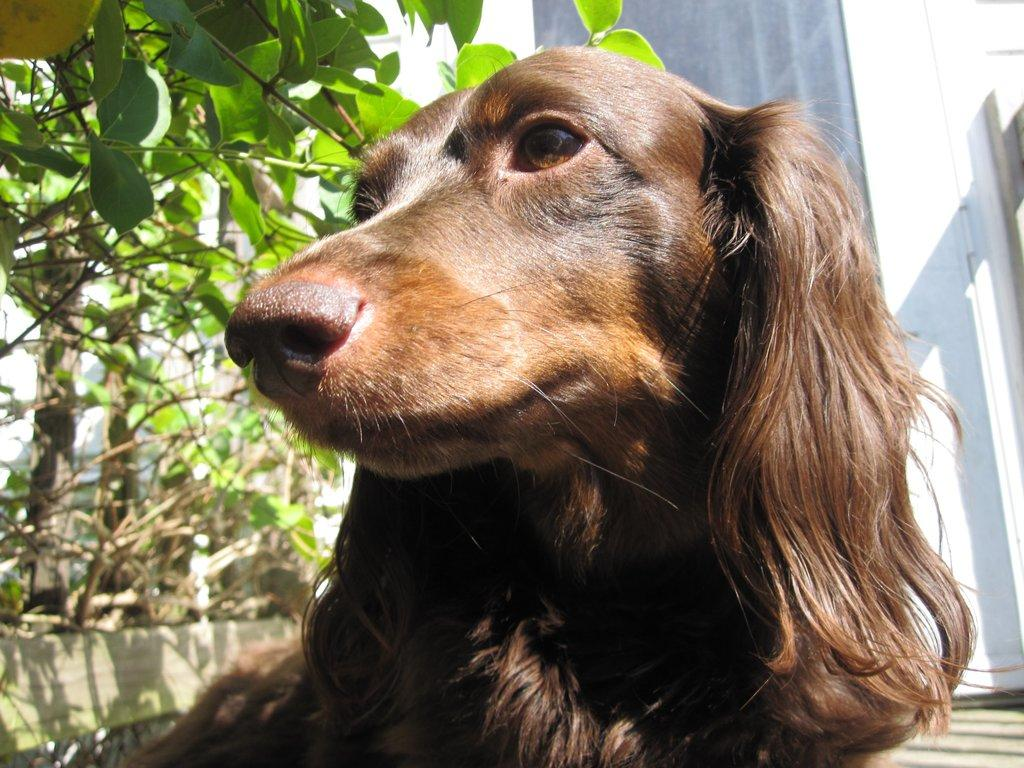What type of animal is in the image? There is a dog in the image. What can be seen in the background of the image? There are plants, a building, and the sky visible in the background of the image. What type of oil can be seen dripping from the dog's fur in the image? There is no oil present in the image, and the dog's fur does not appear to be dripping with any substance. 